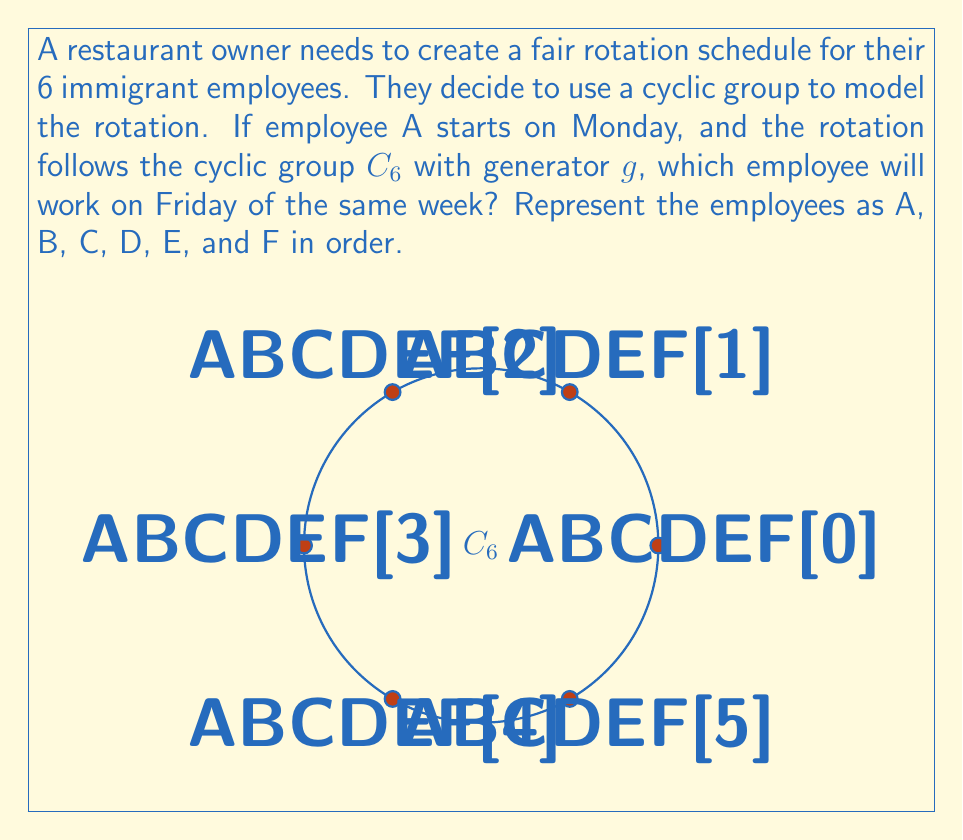What is the answer to this math problem? Let's approach this step-by-step:

1) In the cyclic group $C_6$, each application of the generator $g$ rotates to the next employee in the cycle.

2) We start with A on Monday, so we need to find $g^4$ (4 rotations to get to Friday).

3) In $C_6$, we have:
   $g^1 = $ B
   $g^2 = $ C
   $g^3 = $ D
   $g^4 = $ E

4) We can verify this using modular arithmetic:
   $4 \equiv 4 \pmod{6}$

5) Therefore, after 4 applications of the generator (4 days), we reach employee E.
Answer: E 